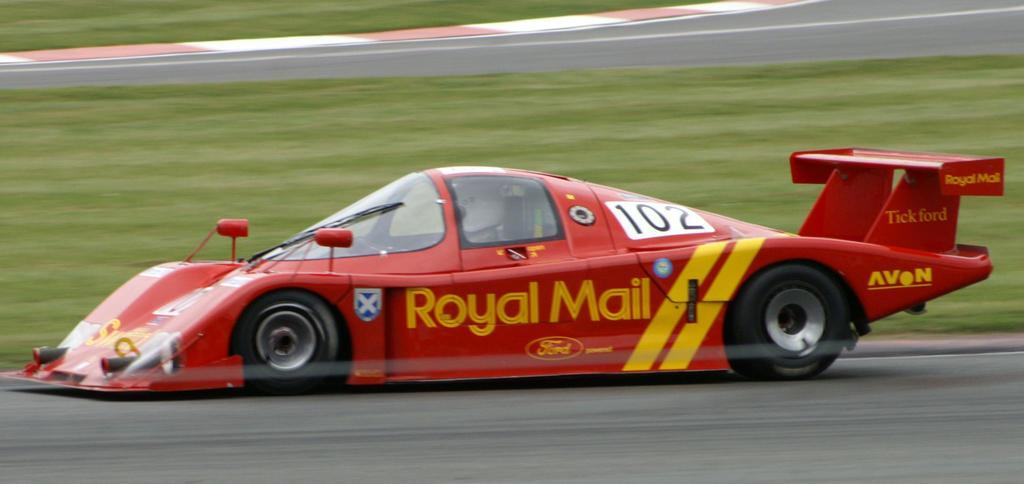What is the main subject of the image? The main subject of the image is a racing car. Where is the racing car located? The racing car is on a track. What can be seen on the other side of the car? There is grass on the surface on the other side of the car. What is the taste of the birds flying in the image? There are no birds present in the image, so it is not possible to determine their taste. 